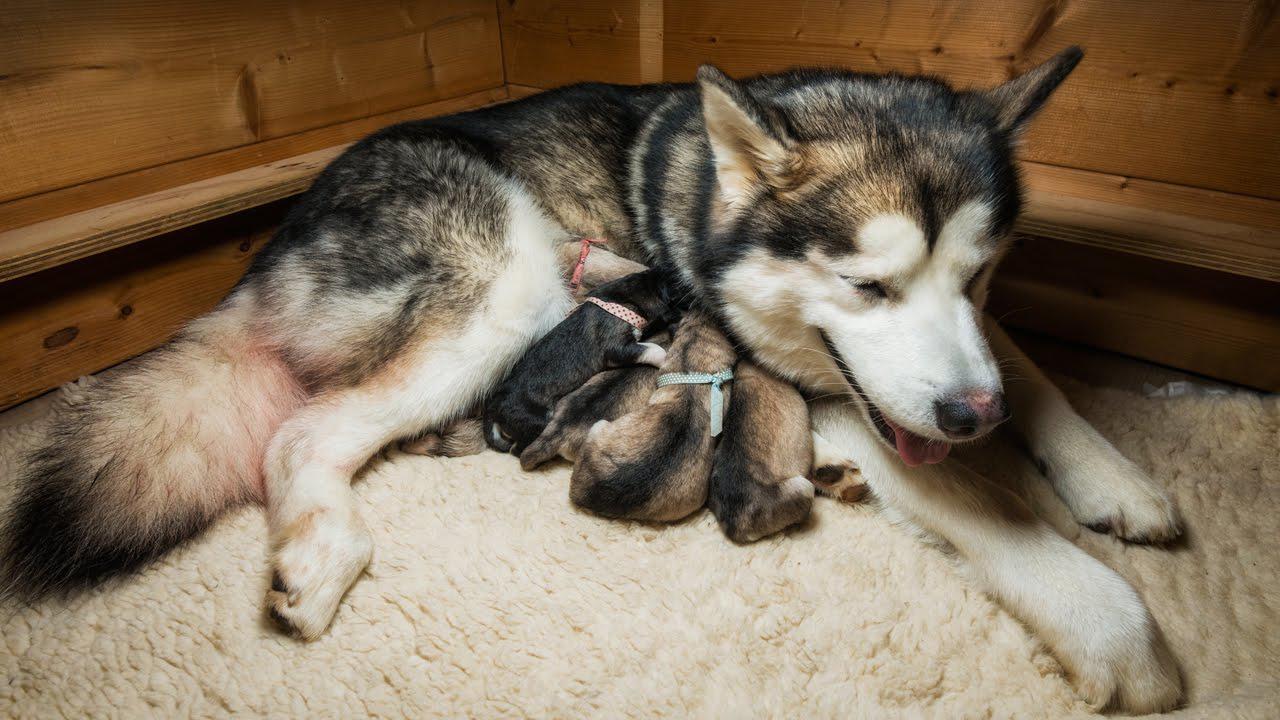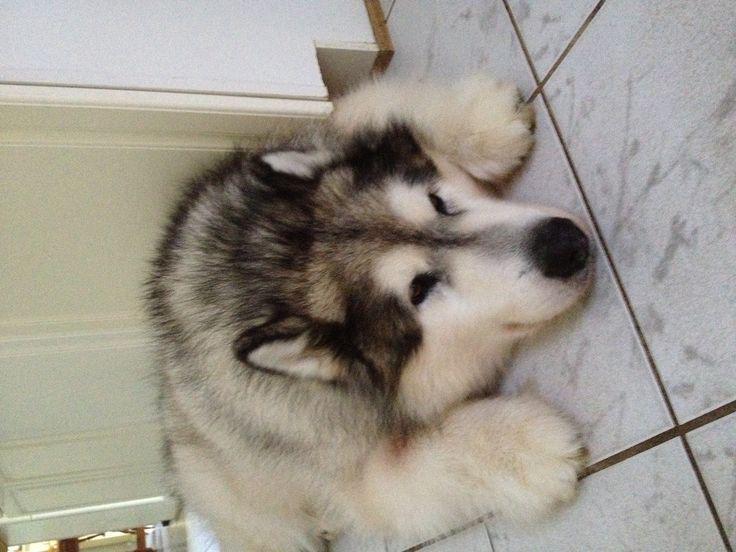The first image is the image on the left, the second image is the image on the right. Examine the images to the left and right. Is the description "A mom dog is with at least one puppy." accurate? Answer yes or no. Yes. The first image is the image on the left, the second image is the image on the right. Assess this claim about the two images: "The left image includes a husky reclining with its head to the right, and the right image includes a husky reclining with front paws forward.". Correct or not? Answer yes or no. Yes. 